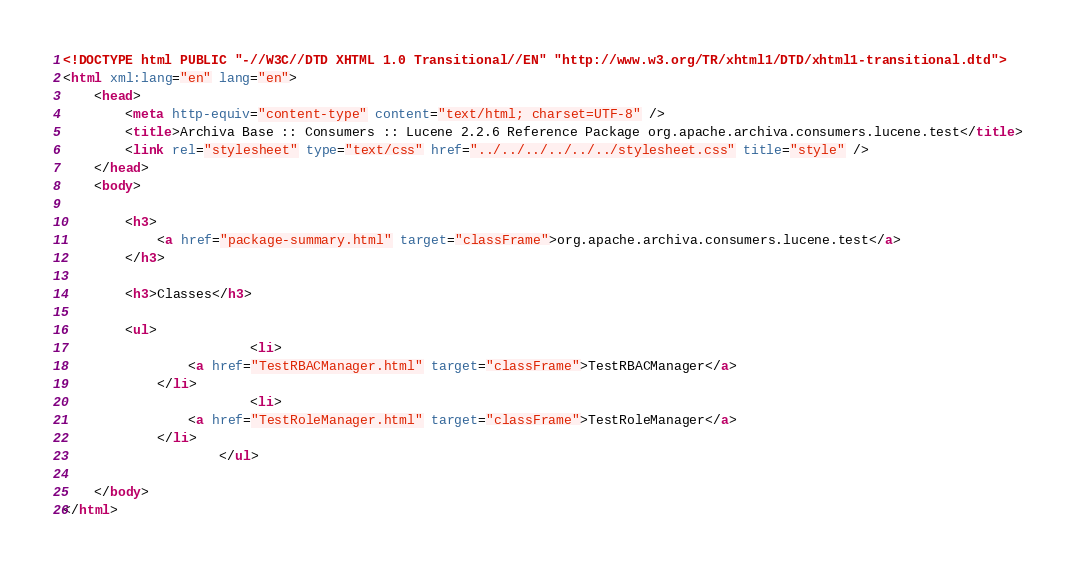Convert code to text. <code><loc_0><loc_0><loc_500><loc_500><_HTML_>
<!DOCTYPE html PUBLIC "-//W3C//DTD XHTML 1.0 Transitional//EN" "http://www.w3.org/TR/xhtml1/DTD/xhtml1-transitional.dtd">
<html xml:lang="en" lang="en">
	<head>
		<meta http-equiv="content-type" content="text/html; charset=UTF-8" />
		<title>Archiva Base :: Consumers :: Lucene 2.2.6 Reference Package org.apache.archiva.consumers.lucene.test</title>
		<link rel="stylesheet" type="text/css" href="../../../../../../stylesheet.css" title="style" />
	</head>
	<body>

		<h3>
        	<a href="package-summary.html" target="classFrame">org.apache.archiva.consumers.lucene.test</a>
      	</h3>

      	<h3>Classes</h3>

      	<ul>
      		          	<li>
            	<a href="TestRBACManager.html" target="classFrame">TestRBACManager</a>
          	</li>
          	          	<li>
            	<a href="TestRoleManager.html" target="classFrame">TestRoleManager</a>
          	</li>
          	      	</ul>

	</body>
</html></code> 